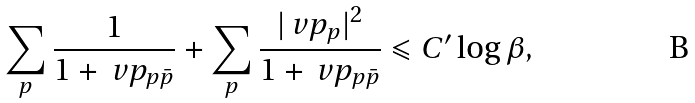<formula> <loc_0><loc_0><loc_500><loc_500>\sum _ { p } \frac { 1 } { 1 + \ v p _ { p \bar { p } } } + \sum _ { p } \frac { | \ v p _ { p } | ^ { 2 } } { 1 + \ v p _ { p \bar { p } } } \leqslant C ^ { \prime } \log \beta ,</formula> 